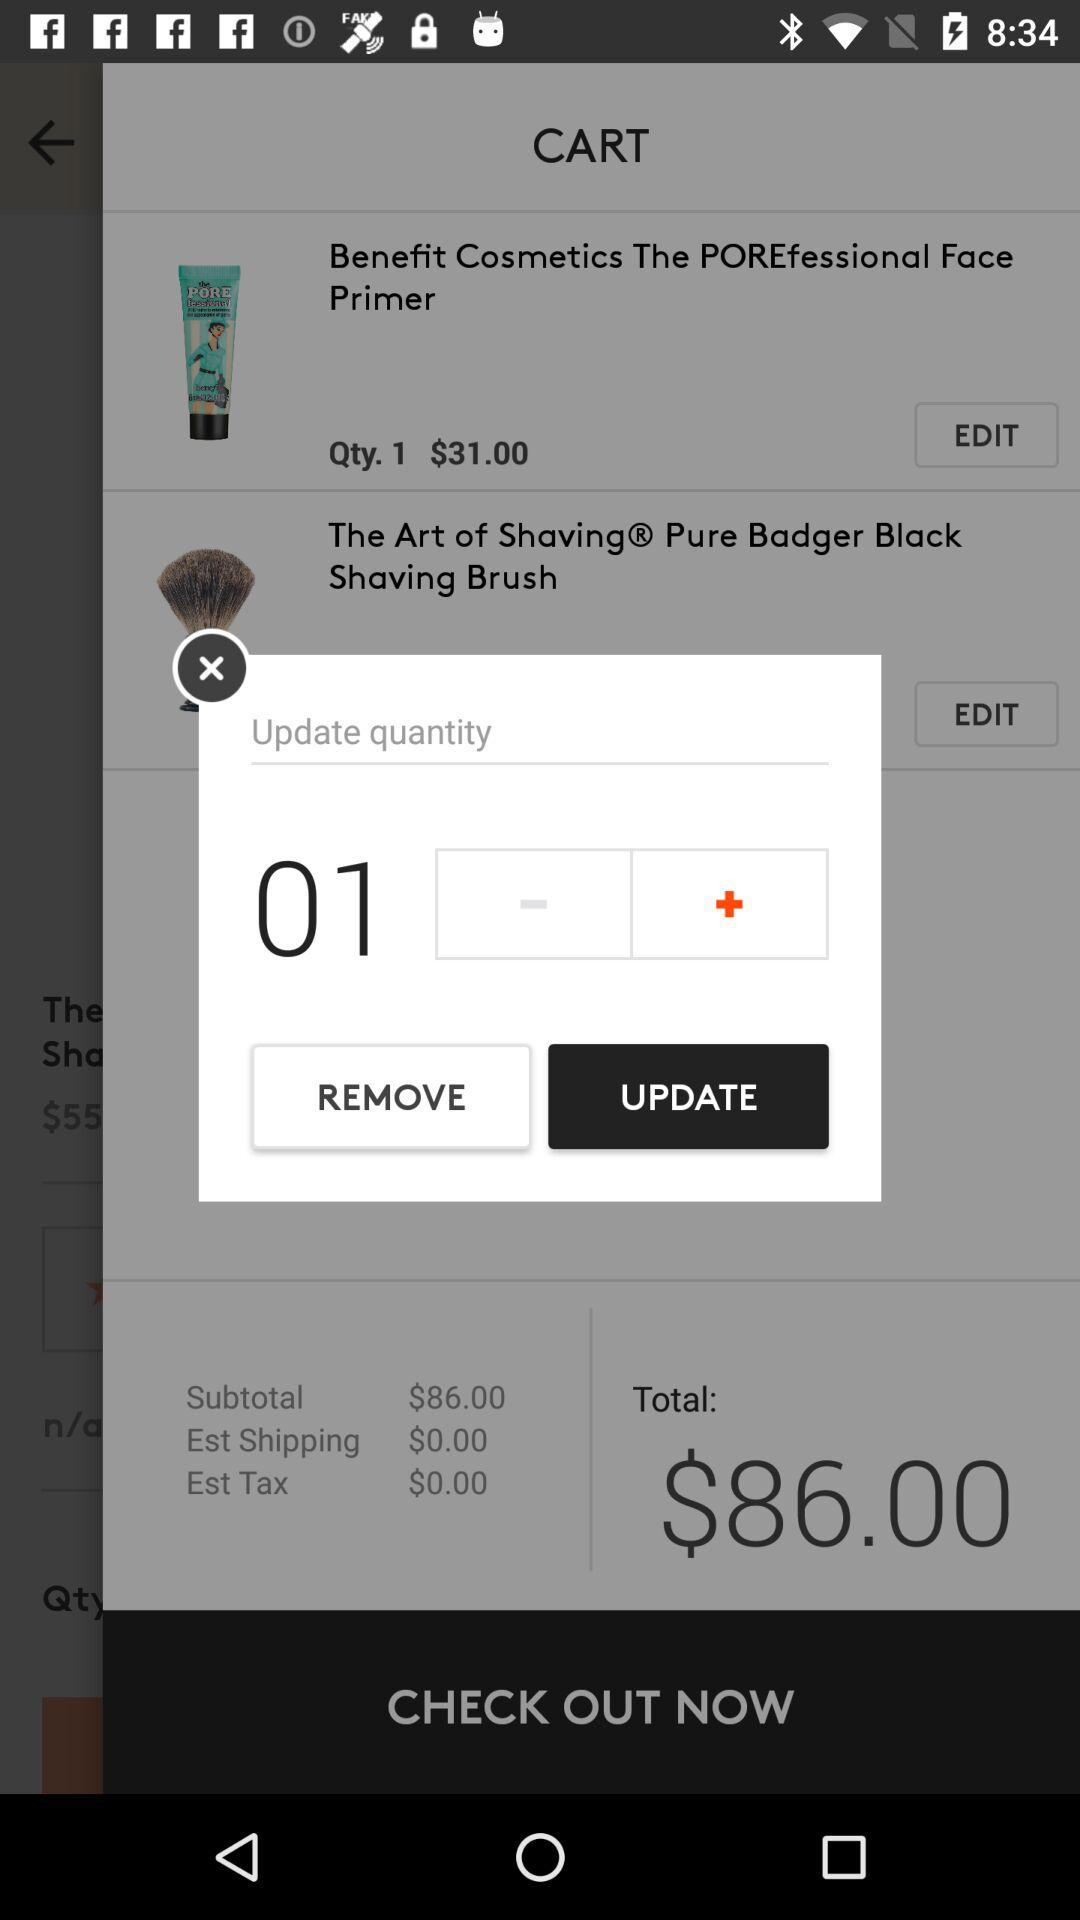How many items are in the cart?
Answer the question using a single word or phrase. 2 